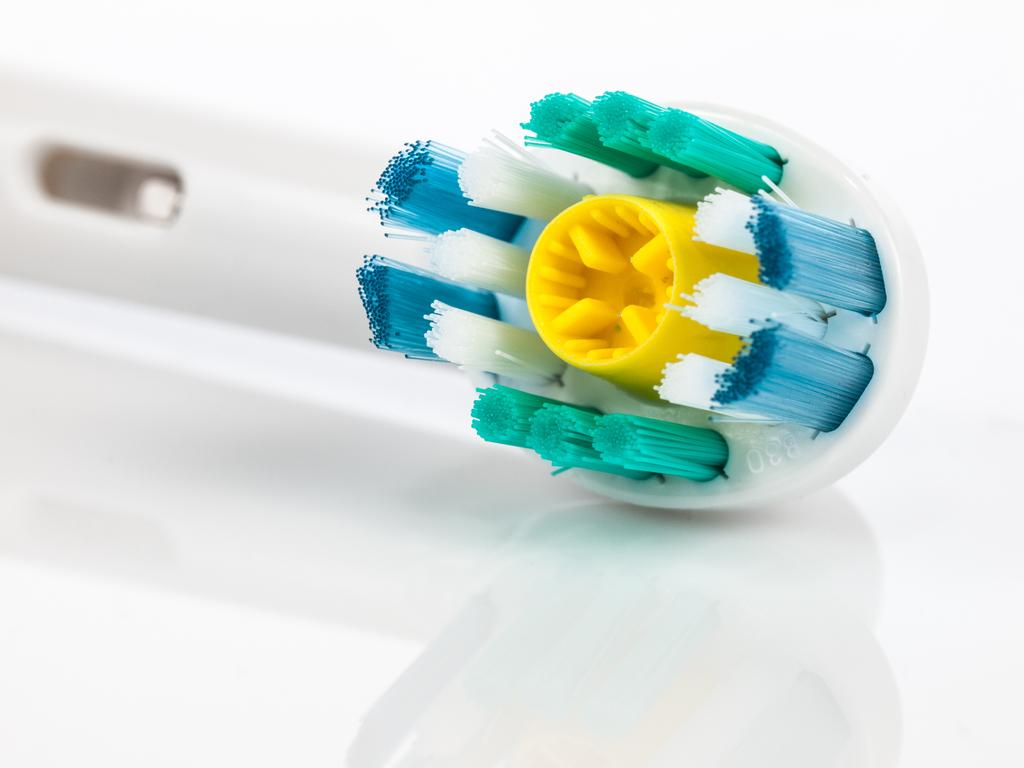What object with a handle can be seen in the image? There is a brush with a handle in the image. What might the brush be used for? The brush could be used for cleaning, grooming, or painting, depending on its type and context. What type of jewel is attached to the brush in the image? There is no jewel attached to the brush in the image. Can you hear the brush coughing in the image? The image is silent, and brushes do not have the ability to cough. 